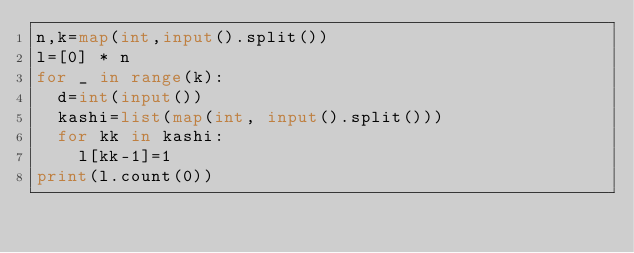Convert code to text. <code><loc_0><loc_0><loc_500><loc_500><_Python_>n,k=map(int,input().split())
l=[0] * n
for _ in range(k):
  d=int(input())
  kashi=list(map(int, input().split()))
  for kk in kashi:
    l[kk-1]=1
print(l.count(0))</code> 